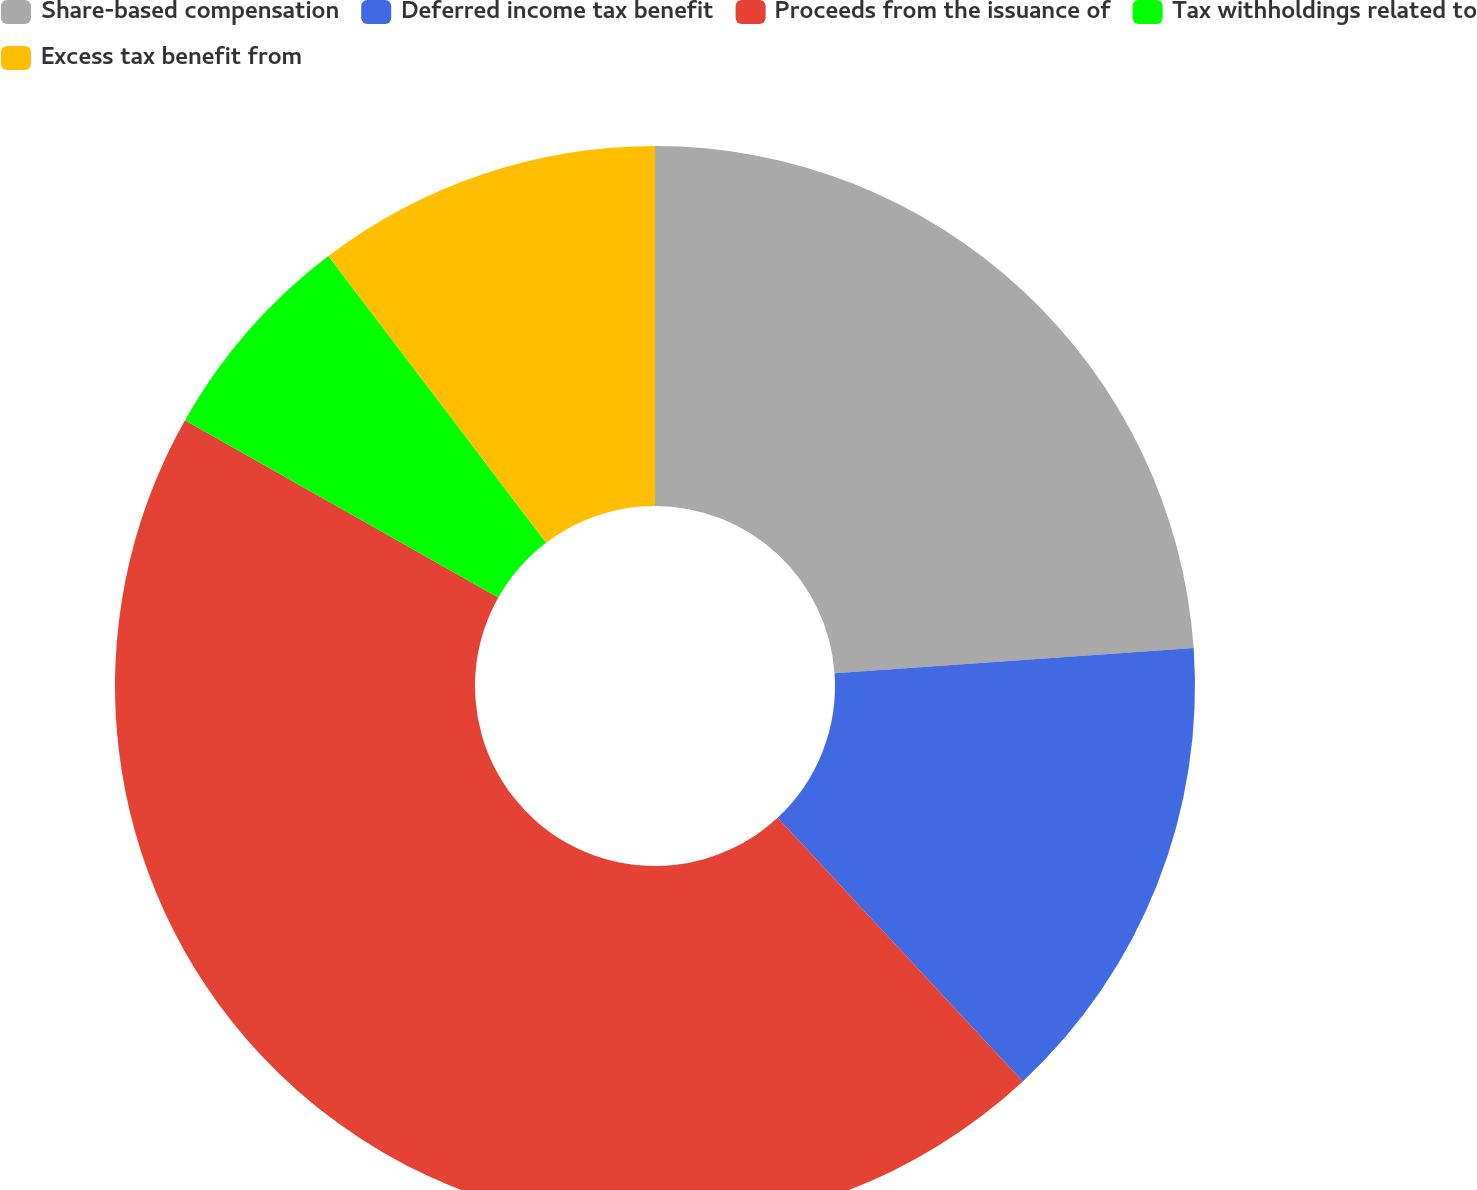<chart> <loc_0><loc_0><loc_500><loc_500><pie_chart><fcel>Share-based compensation<fcel>Deferred income tax benefit<fcel>Proceeds from the issuance of<fcel>Tax withholdings related to<fcel>Excess tax benefit from<nl><fcel>23.88%<fcel>14.2%<fcel>45.12%<fcel>6.47%<fcel>10.34%<nl></chart> 